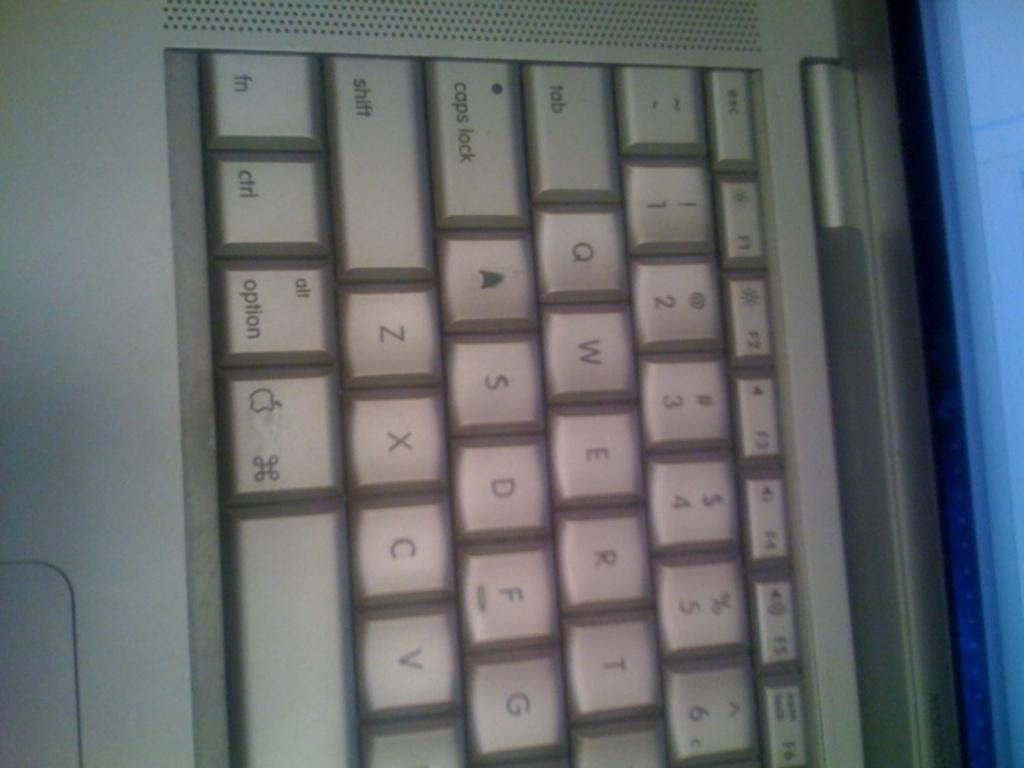<image>
Offer a succinct explanation of the picture presented. A computer keyboard includes a caps lock key and a key that says option. 